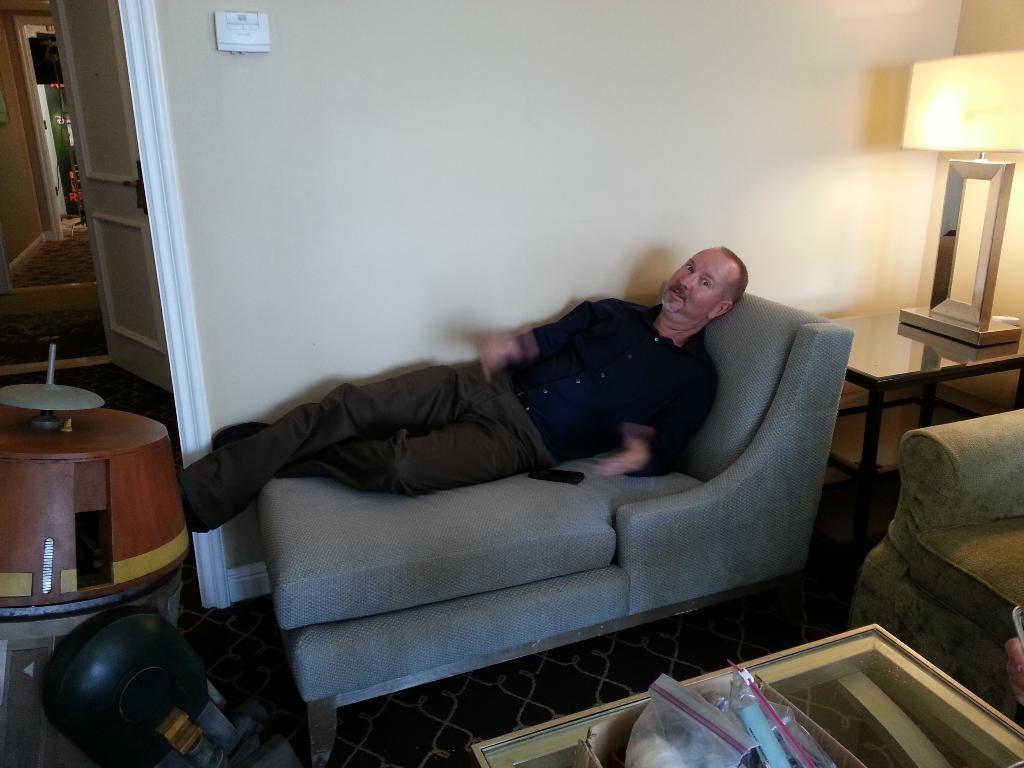Can you describe this image briefly? In the middle a man is sleeping on the sofa bed and in the right it's a bed lamp the left side of an image it's a door and it's a wall. 